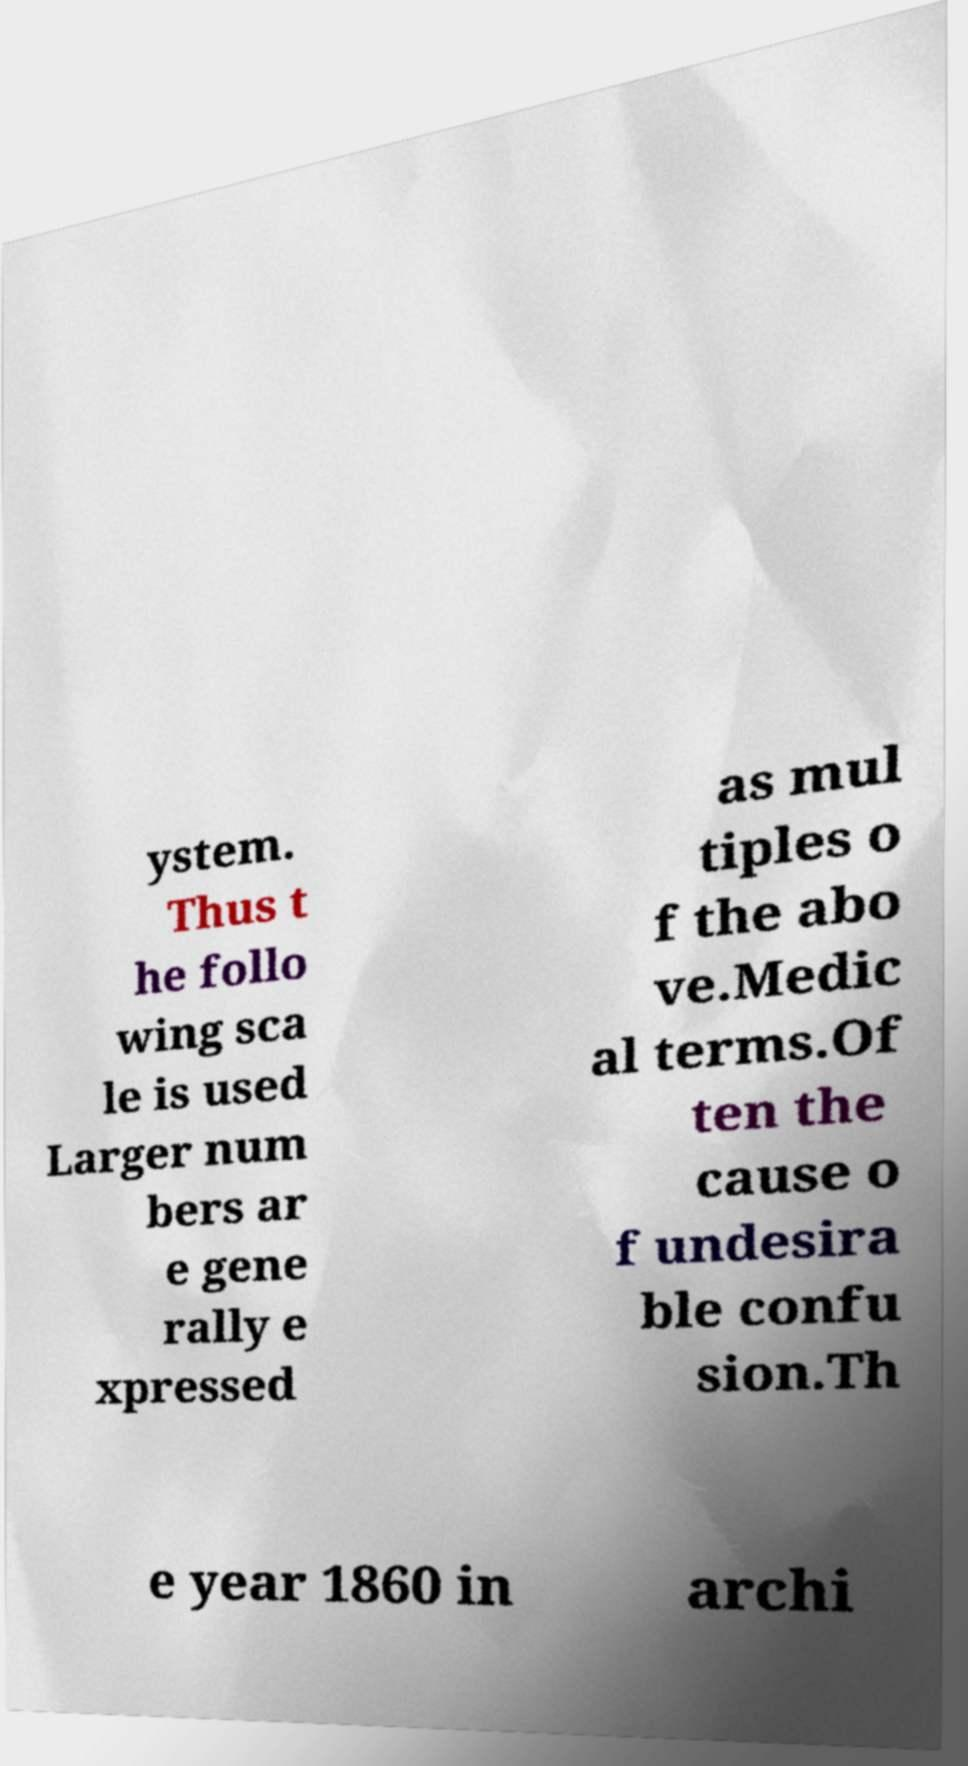Can you accurately transcribe the text from the provided image for me? ystem. Thus t he follo wing sca le is used Larger num bers ar e gene rally e xpressed as mul tiples o f the abo ve.Medic al terms.Of ten the cause o f undesira ble confu sion.Th e year 1860 in archi 